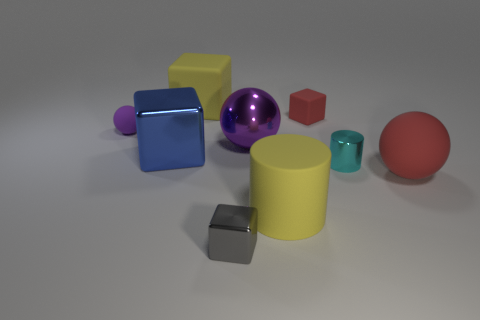Subtract all blue blocks. How many blocks are left? 3 Add 1 red shiny cubes. How many objects exist? 10 Subtract all purple cylinders. How many purple spheres are left? 2 Subtract all red spheres. How many spheres are left? 2 Subtract 1 balls. How many balls are left? 2 Subtract all balls. How many objects are left? 6 Subtract all small rubber objects. Subtract all tiny red cubes. How many objects are left? 6 Add 5 gray objects. How many gray objects are left? 6 Add 4 gray shiny cubes. How many gray shiny cubes exist? 5 Subtract 0 green cylinders. How many objects are left? 9 